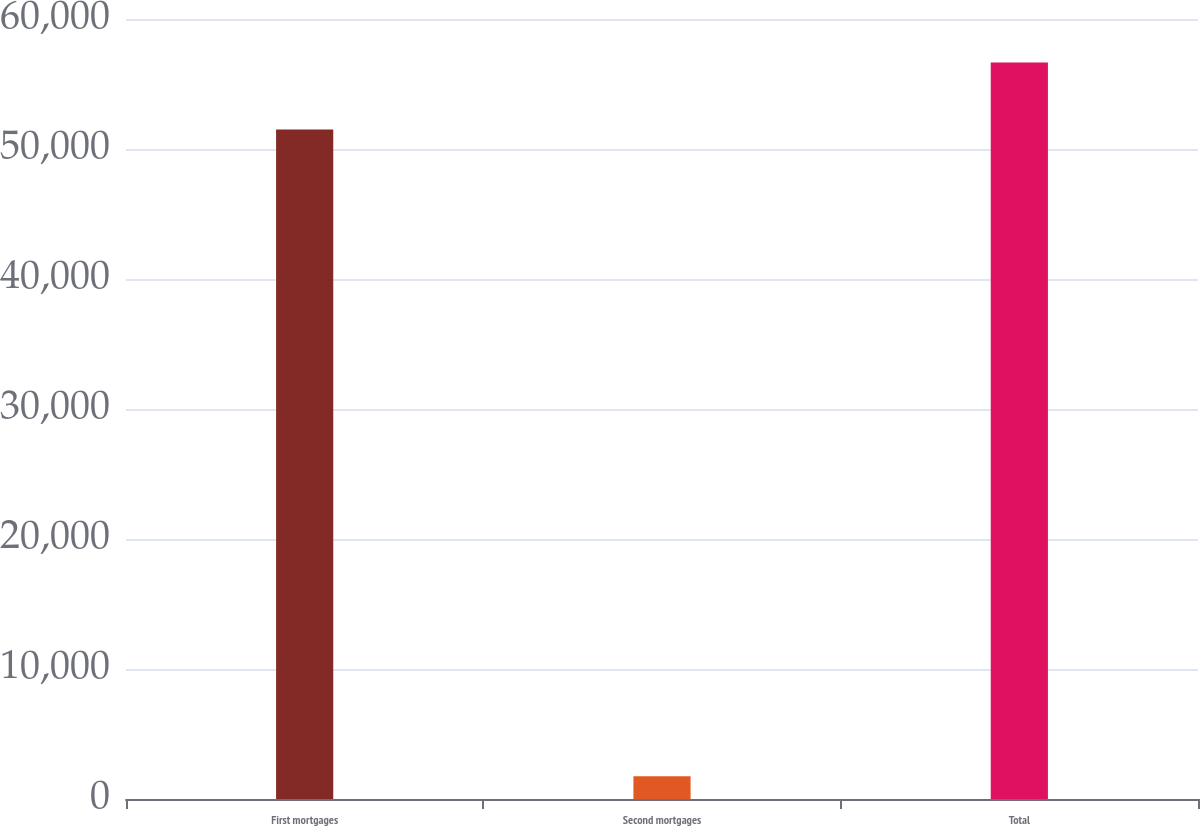<chart> <loc_0><loc_0><loc_500><loc_500><bar_chart><fcel>First mortgages<fcel>Second mortgages<fcel>Total<nl><fcel>51495<fcel>1752<fcel>56644.5<nl></chart> 